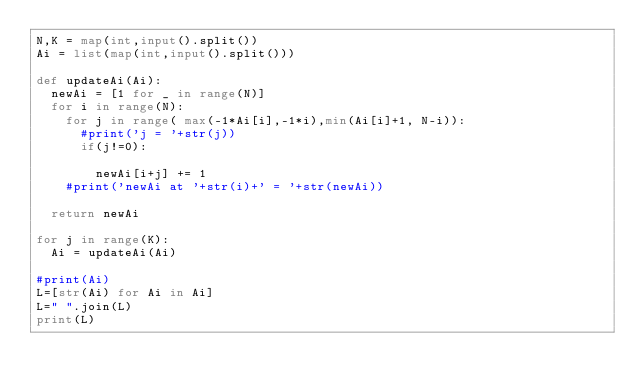Convert code to text. <code><loc_0><loc_0><loc_500><loc_500><_Python_>N,K = map(int,input().split())
Ai = list(map(int,input().split()))	

def updateAi(Ai):
  newAi = [1 for _ in range(N)]
  for i in range(N):
    for j in range( max(-1*Ai[i],-1*i),min(Ai[i]+1, N-i)):
      #print('j = '+str(j))
      if(j!=0):
        
        newAi[i+j] += 1
    #print('newAi at '+str(i)+' = '+str(newAi))
  
  return newAi

for j in range(K):
  Ai = updateAi(Ai)

#print(Ai)
L=[str(Ai) for Ai in Ai]
L=" ".join(L)
print(L)</code> 